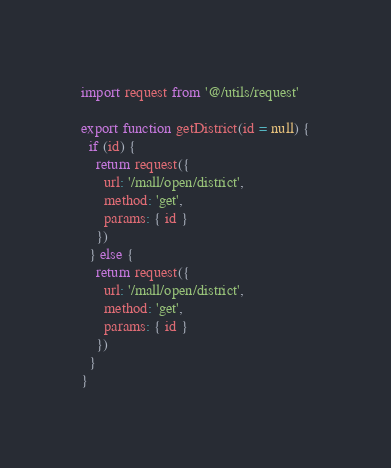Convert code to text. <code><loc_0><loc_0><loc_500><loc_500><_JavaScript_>import request from '@/utils/request'

export function getDistrict(id = null) {
  if (id) {
    return request({
      url: '/mall/open/district',
      method: 'get',
      params: { id }
    })
  } else {
    return request({
      url: '/mall/open/district',
      method: 'get',
      params: { id }
    })
  }
}
</code> 